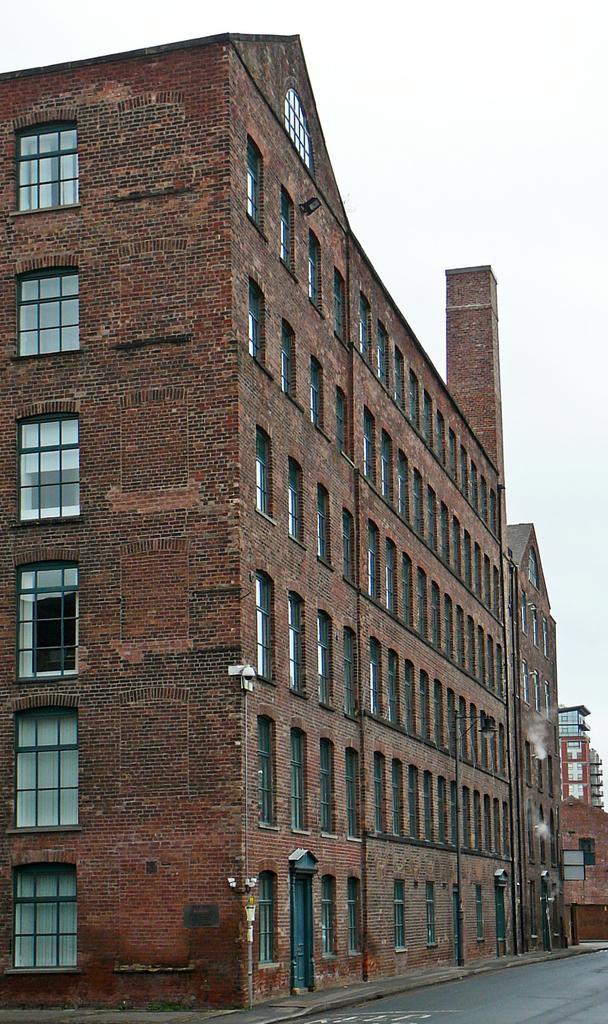Describe this image in one or two sentences. Here in this picture we can see buildings present all over there and we can see windows and doors of it on the building over there and we can see light posts here and there. 